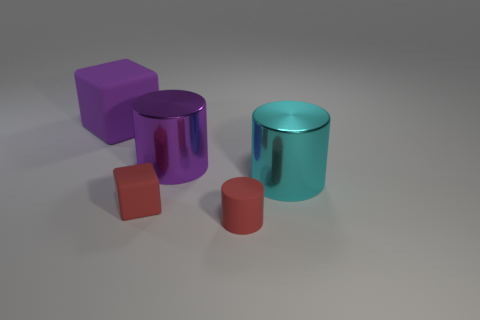What shape is the large purple object on the right side of the cube behind the big purple cylinder?
Provide a succinct answer. Cylinder. There is a metallic cylinder that is to the left of the metal object on the right side of the small rubber object to the right of the big purple cylinder; what size is it?
Offer a very short reply. Large. Is the red rubber cylinder the same size as the purple cylinder?
Ensure brevity in your answer.  No. How many objects are either large cyan cubes or big cyan metal objects?
Offer a terse response. 1. There is a rubber thing that is behind the red rubber object that is left of the red cylinder; what is its size?
Provide a succinct answer. Large. What is the size of the purple shiny cylinder?
Give a very brief answer. Large. What shape is the object that is behind the red cylinder and on the right side of the purple cylinder?
Your response must be concise. Cylinder. What is the color of the other shiny thing that is the same shape as the purple metallic thing?
Your answer should be compact. Cyan. What number of objects are red rubber things behind the red cylinder or red matte cubes behind the red matte cylinder?
Make the answer very short. 1. What shape is the big matte thing?
Keep it short and to the point. Cube. 